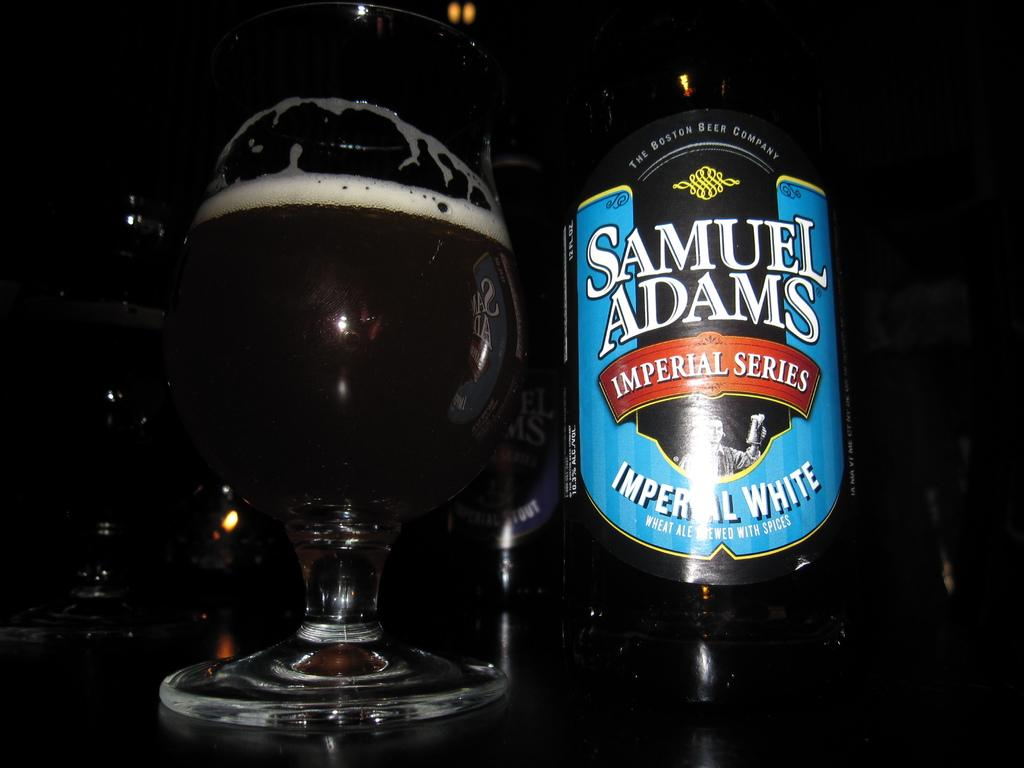<image>
Present a compact description of the photo's key features. A bottle of Samuel Adams beer, specifically the Imperial White variety. 